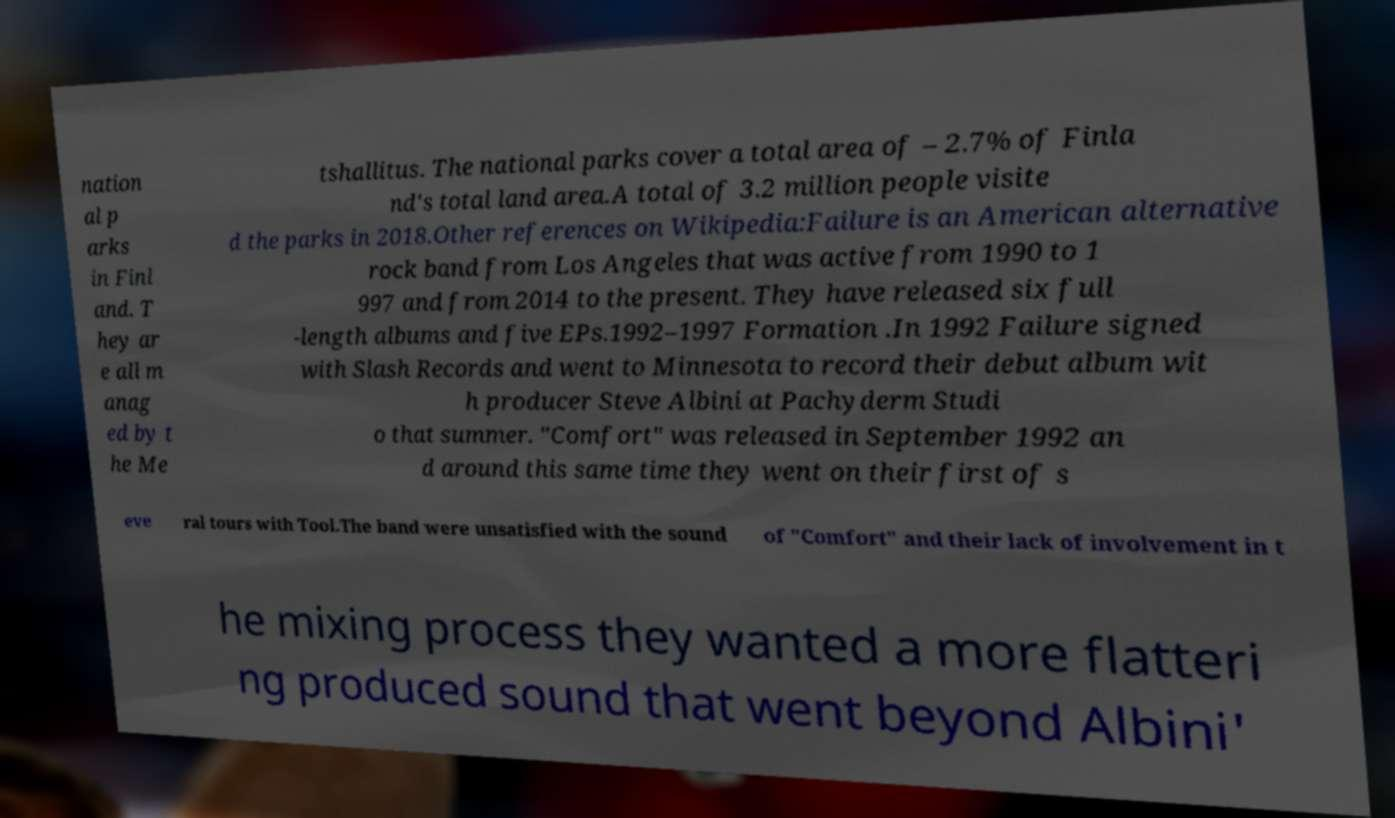There's text embedded in this image that I need extracted. Can you transcribe it verbatim? nation al p arks in Finl and. T hey ar e all m anag ed by t he Me tshallitus. The national parks cover a total area of – 2.7% of Finla nd's total land area.A total of 3.2 million people visite d the parks in 2018.Other references on Wikipedia:Failure is an American alternative rock band from Los Angeles that was active from 1990 to 1 997 and from 2014 to the present. They have released six full -length albums and five EPs.1992–1997 Formation .In 1992 Failure signed with Slash Records and went to Minnesota to record their debut album wit h producer Steve Albini at Pachyderm Studi o that summer. "Comfort" was released in September 1992 an d around this same time they went on their first of s eve ral tours with Tool.The band were unsatisfied with the sound of "Comfort" and their lack of involvement in t he mixing process they wanted a more flatteri ng produced sound that went beyond Albini' 